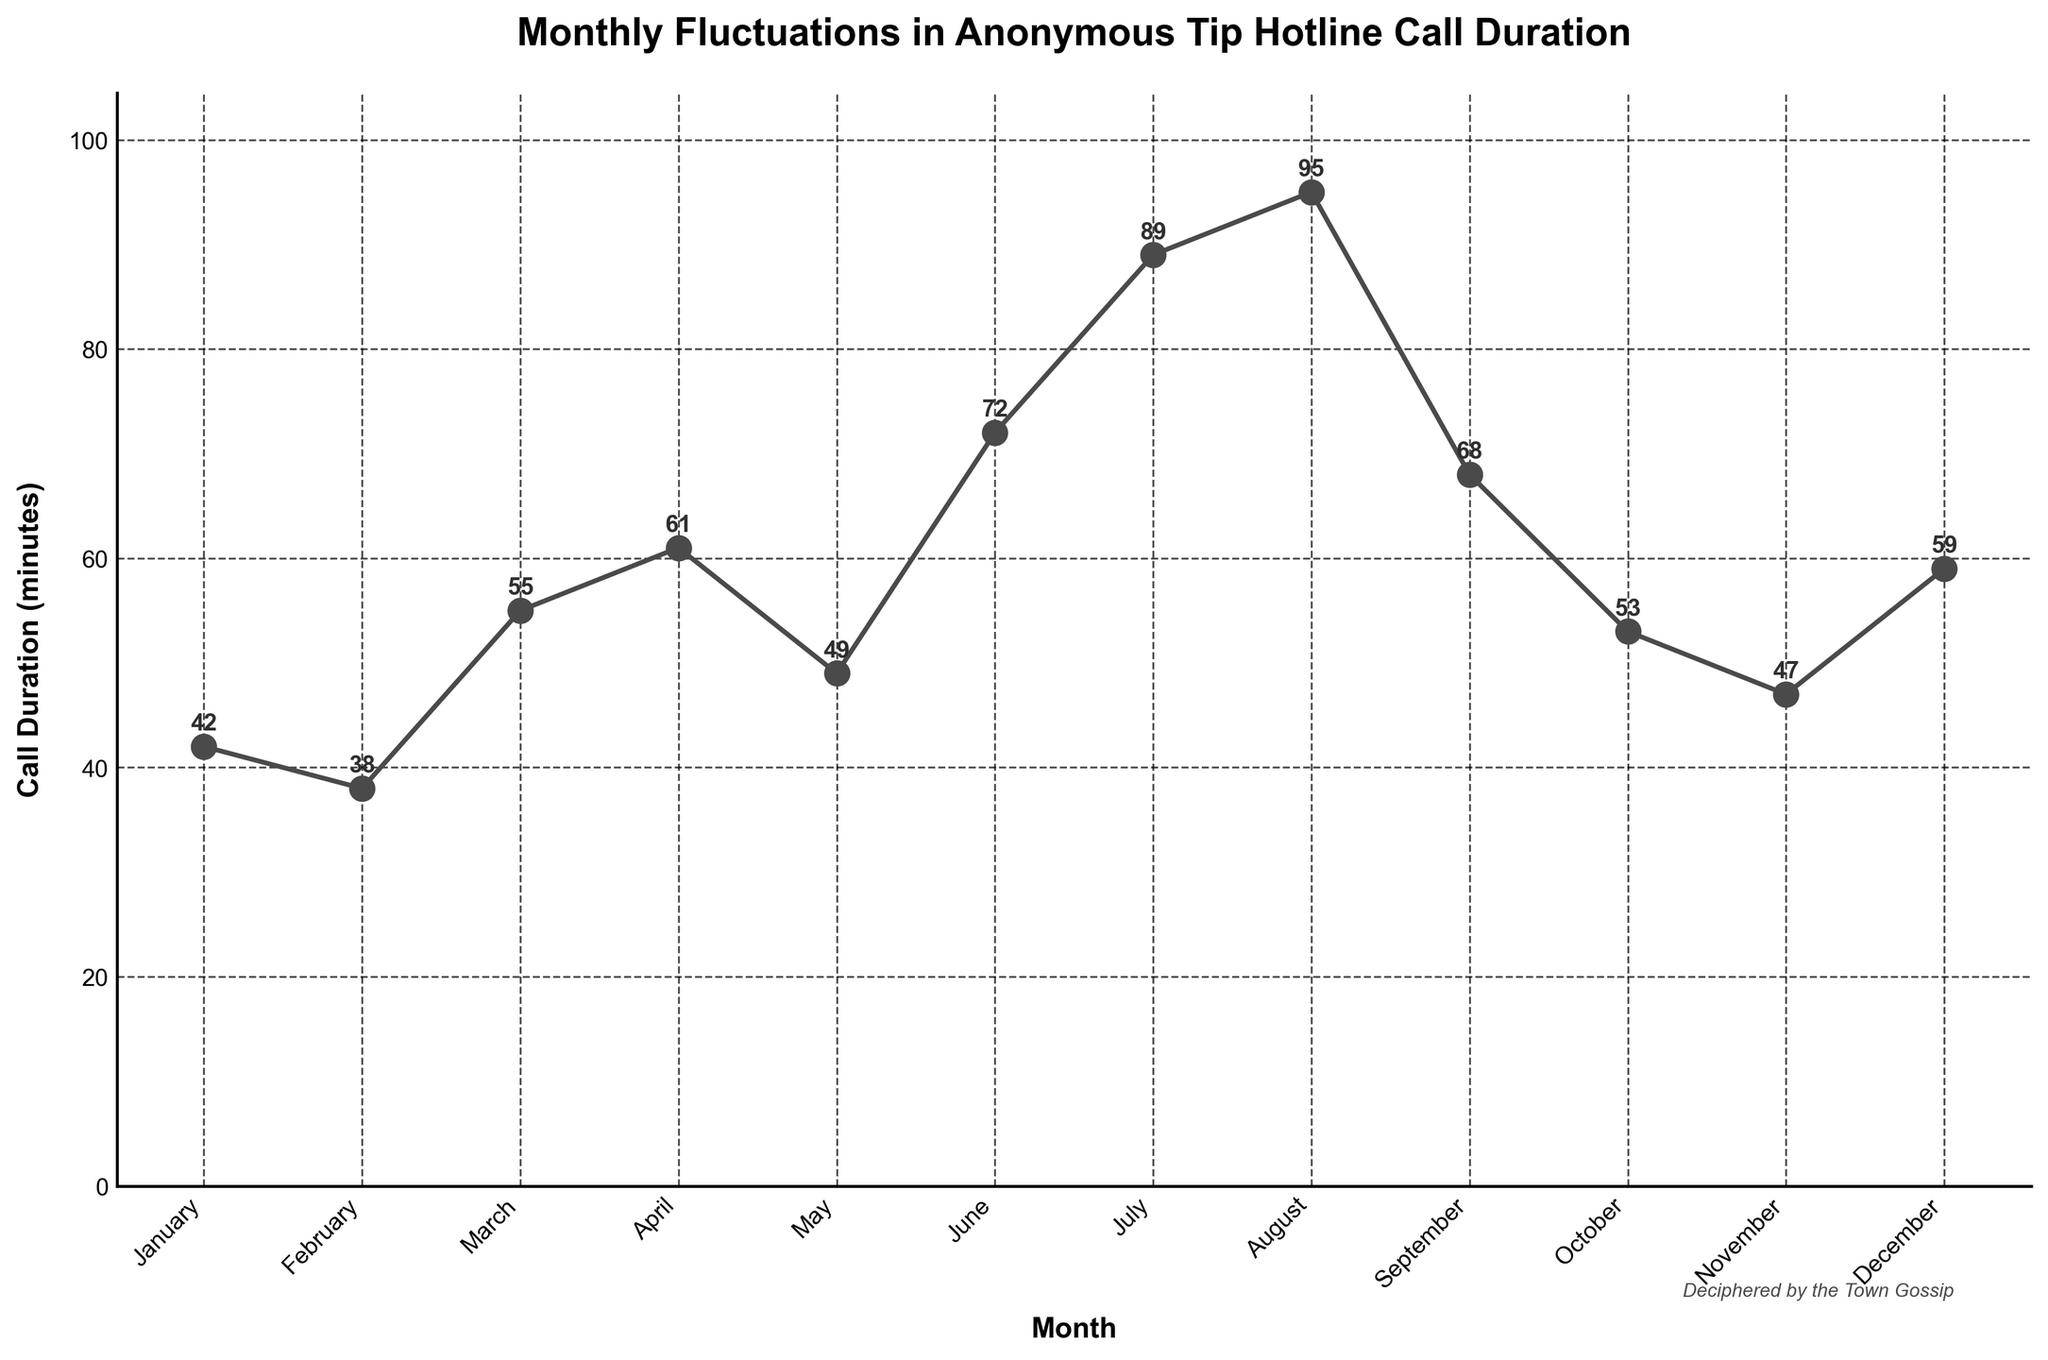Which month had the longest call duration? According to the plotted data, the call duration in August was the highest at 95 minutes.
Answer: August Which month had the shortest call duration? January recorded the shortest call duration at 38 minutes as shown in the chart.
Answer: January What is the difference in call duration between the longest and shortest months? The longest call duration is 95 minutes (August) and the shortest is 38 minutes (January). The difference is 95 - 38 = 57 minutes.
Answer: 57 minutes How does the call duration in July compare to that in March? The call duration in July is 89 minutes, whereas in March it is 55 minutes. Thus, July has a higher call duration than March.
Answer: July is higher What is the average call duration over the year? The sum of the call durations from each month is 42+38+55+61+49+72+89+95+68+53+47+59 = 728 minutes. There are 12 months. The average call duration is 728/12 ≈ 60.67 minutes.
Answer: 60.67 minutes Which months have a call duration greater than 50 minutes? The months with call durations greater than 50 minutes are March (55), April (61), June (72), July (89), August (95), September (68), and October (53).
Answer: March, April, June, July, August, September, October In which season do the call durations peak? (Assuming winter is Dec-Feb, spring is Mar-May, summer is Jun-Aug, and fall is Sep-Nov) Call durations peak during summer, with July at 89 minutes and August at 95 minutes.
Answer: Summer What is the total call duration for the first half of the year (Jan-Jun)? The sum of call durations for January to June is 42 + 38 + 55 + 61 + 49 + 72 = 317 minutes.
Answer: 317 minutes Which month saw a bigger increase in call duration compared to the previous month, April or June? The increase from March (55) to April (61) is 61 - 55 = 6 minutes. The increase from May (49) to June (72) is 72 - 49 = 23 minutes. June saw a bigger increase.
Answer: June How many months had a call duration longer than the yearly average? The yearly average is approximately 60.67 minutes. The months with durations above this average are April (61), June (72), July (89), August (95), September (68), and October (53). Six months had call durations longer than the average.
Answer: 6 months 